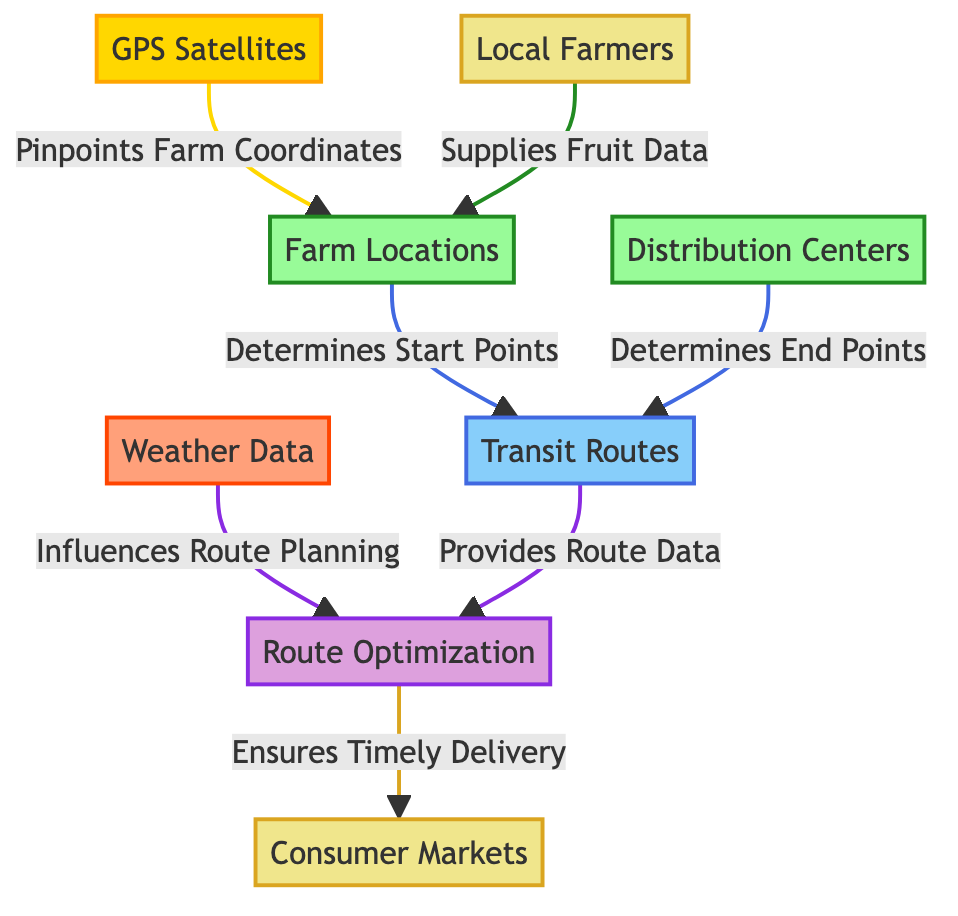What represents the starting points for transit routes? The diagram shows that farm locations determine the start points for transit routes, as indicated by the arrow leading from the farms node to the routes node.
Answer: Farm Locations How many types of nodes are present in the diagram? By counting the distinct types of nodes represented (GPS satellites, farm locations, distribution centers, transit routes, weather data, route optimization, local farmers, consumer markets), we find there are seven types.
Answer: Seven What is the role of the weather data in route planning? Weather data influences route planning, as indicated by the arrow connecting the weather node to the route optimization node, showing that weather conditions are a factor in how routes are optimized.
Answer: Influences Route Planning Which node connects the farmers to the farms? The diagram indicates that local farmers supply fruit data to the farm locations, establishing a connection between the farmers node and the farms node.
Answer: Local Farmers How does the route optimization ensure timely delivery? The optimization node processes both route data and weather data to ensure that the delivery to consumer markets is timely. This involves evaluating the routes based on weather influences and the data provided by farm locations.
Answer: Ensures Timely Delivery Which nodes are categorized as locations in the diagram? The nodes categorized as locations in the diagram include farm locations and distribution centers, both of which are visually classified under the same color and labeled accordingly.
Answer: Farm Locations, Distribution Centers What does the GPS satellites node provide? The GPS satellites node pinpoints the coordinates of farms, which is crucial for determining the starting points for distribution routes. This direct connection shows its function clearly.
Answer: Pinpoints Farm Coordinates What is the final destination of the optimized routes? The diagram specifies that the output of the route optimization process leads directly to consumer markets, indicating that this is where the optimized routes ultimately direct their deliveries.
Answer: Consumer Markets 